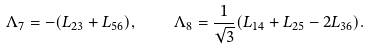Convert formula to latex. <formula><loc_0><loc_0><loc_500><loc_500>\Lambda _ { 7 } = - ( L _ { 2 3 } + L _ { 5 6 } ) , \quad \Lambda _ { 8 } = \frac { 1 } { \sqrt { 3 } } ( L _ { 1 4 } + L _ { 2 5 } - 2 L _ { 3 6 } ) .</formula> 